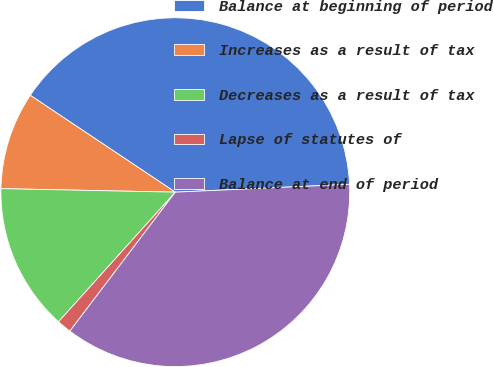<chart> <loc_0><loc_0><loc_500><loc_500><pie_chart><fcel>Balance at beginning of period<fcel>Increases as a result of tax<fcel>Decreases as a result of tax<fcel>Lapse of statutes of<fcel>Balance at end of period<nl><fcel>39.91%<fcel>9.05%<fcel>13.65%<fcel>1.34%<fcel>36.05%<nl></chart> 